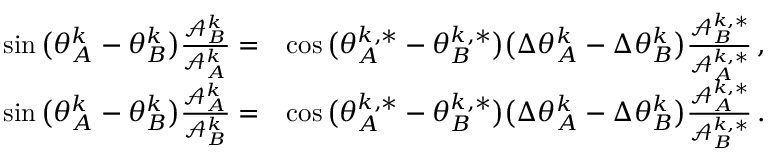Convert formula to latex. <formula><loc_0><loc_0><loc_500><loc_500>\begin{array} { r l } { \sin \left ( \theta _ { A } ^ { k } - \theta _ { B } ^ { k } \right ) \frac { \mathcal { A } _ { B } ^ { k } } { \mathcal { A } _ { A } ^ { k } } = } & { \cos \left ( \theta _ { A } ^ { k , * } - \theta _ { B } ^ { k , * } \right ) \left ( \Delta \theta _ { A } ^ { k } - \Delta \theta _ { B } ^ { k } \right ) \frac { \mathcal { A } _ { B } ^ { k , * } } { \mathcal { A } _ { A } ^ { k , * } } \, , } \\ { \sin \left ( \theta _ { A } ^ { k } - \theta _ { B } ^ { k } \right ) \frac { \mathcal { A } _ { A } ^ { k } } { \mathcal { A } _ { B } ^ { k } } = } & { \cos \left ( \theta _ { A } ^ { k , * } - \theta _ { B } ^ { k , * } \right ) \left ( \Delta \theta _ { A } ^ { k } - \Delta \theta _ { B } ^ { k } \right ) \frac { \mathcal { A } _ { A } ^ { k , * } } { \mathcal { A } _ { B } ^ { k , * } } \, . } \end{array}</formula> 